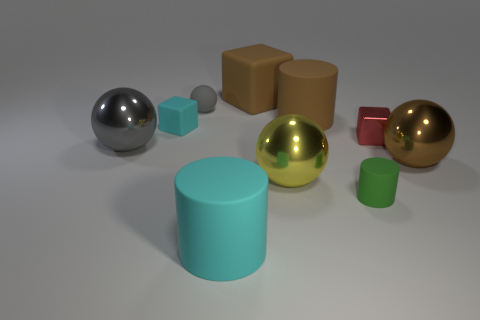Subtract all blocks. How many objects are left? 7 Add 9 tiny gray shiny blocks. How many tiny gray shiny blocks exist? 9 Subtract 1 brown cylinders. How many objects are left? 9 Subtract all big objects. Subtract all small matte spheres. How many objects are left? 3 Add 2 brown things. How many brown things are left? 5 